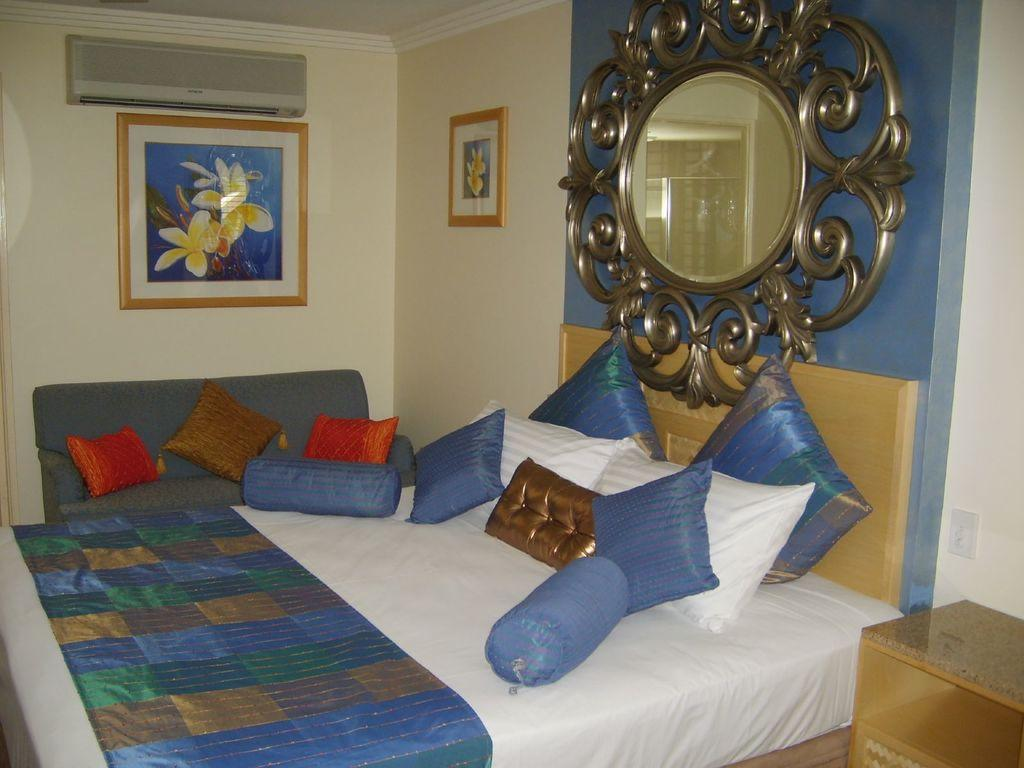What type of space is depicted in the image? There is a room in the image. What furniture is present in the room? There are beds, a sofa, and a mirror in the room. What can be found on the beds? The beds have bed sheets and pillows. What is the purpose of the frame on the wall? The frame on the wall is likely used for displaying artwork or photographs. What device is present for temperature control in the room? There is an air conditioner (AC) in the room. What type of corn can be seen growing in the room? There is no corn present in the room; it is an indoor space with furniture and other objects. 